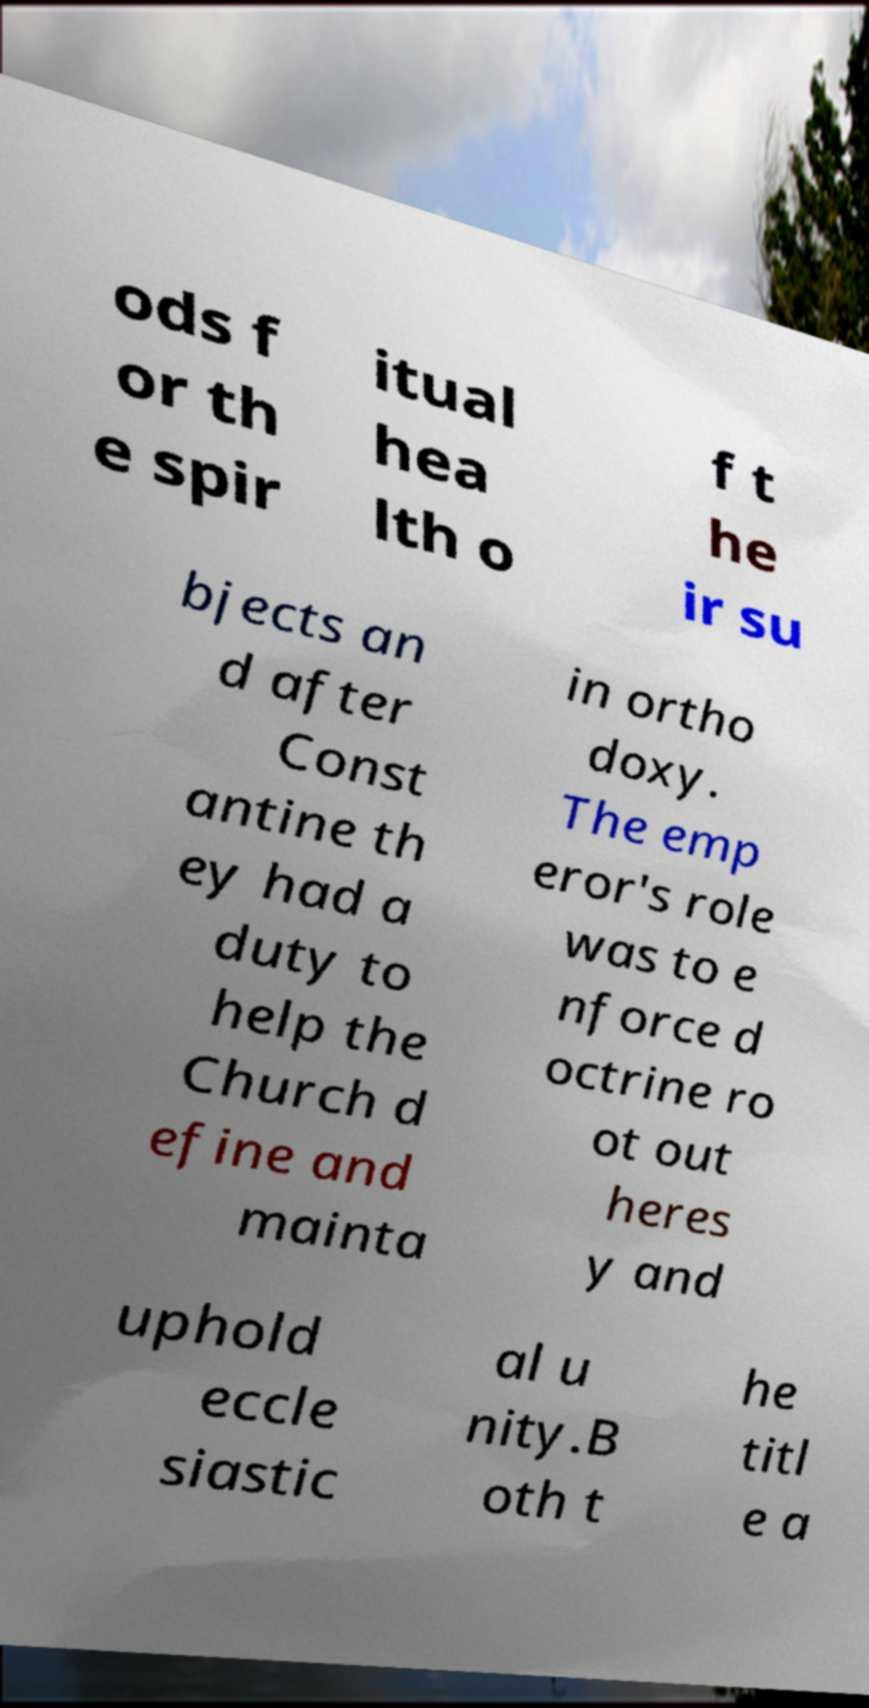Can you accurately transcribe the text from the provided image for me? ods f or th e spir itual hea lth o f t he ir su bjects an d after Const antine th ey had a duty to help the Church d efine and mainta in ortho doxy. The emp eror's role was to e nforce d octrine ro ot out heres y and uphold eccle siastic al u nity.B oth t he titl e a 